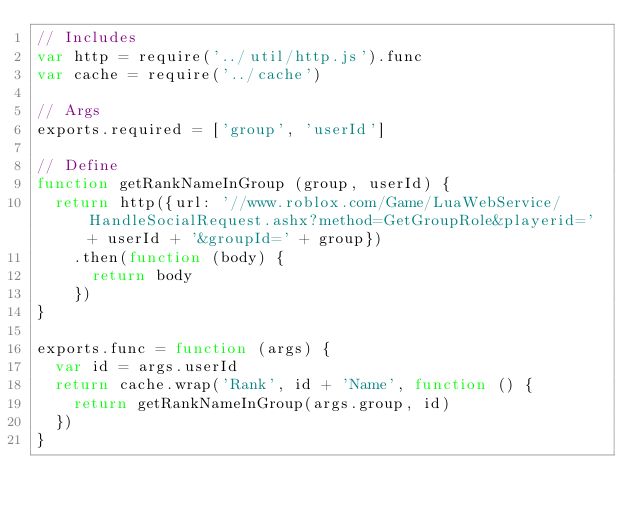Convert code to text. <code><loc_0><loc_0><loc_500><loc_500><_JavaScript_>// Includes
var http = require('../util/http.js').func
var cache = require('../cache')

// Args
exports.required = ['group', 'userId']

// Define
function getRankNameInGroup (group, userId) {
  return http({url: '//www.roblox.com/Game/LuaWebService/HandleSocialRequest.ashx?method=GetGroupRole&playerid=' + userId + '&groupId=' + group})
    .then(function (body) {
      return body
    })
}

exports.func = function (args) {
  var id = args.userId
  return cache.wrap('Rank', id + 'Name', function () {
    return getRankNameInGroup(args.group, id)
  })
}
</code> 